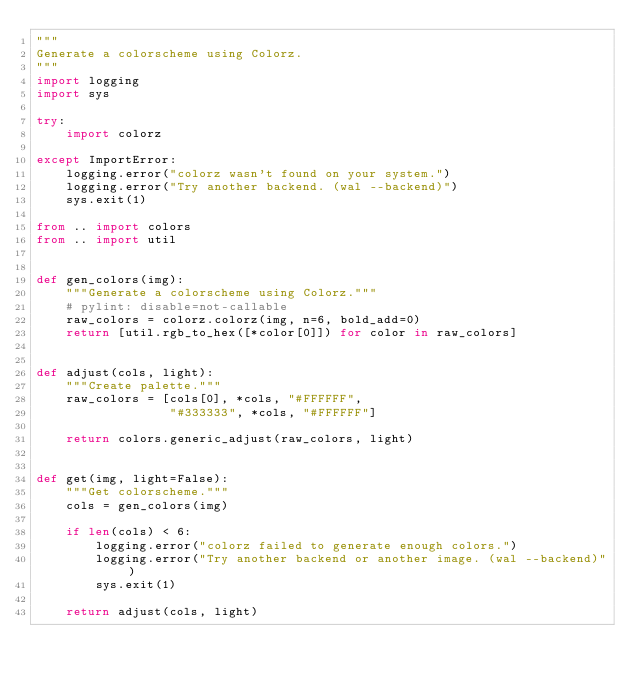Convert code to text. <code><loc_0><loc_0><loc_500><loc_500><_Python_>"""
Generate a colorscheme using Colorz.
"""
import logging
import sys

try:
    import colorz

except ImportError:
    logging.error("colorz wasn't found on your system.")
    logging.error("Try another backend. (wal --backend)")
    sys.exit(1)

from .. import colors
from .. import util


def gen_colors(img):
    """Generate a colorscheme using Colorz."""
    # pylint: disable=not-callable
    raw_colors = colorz.colorz(img, n=6, bold_add=0)
    return [util.rgb_to_hex([*color[0]]) for color in raw_colors]


def adjust(cols, light):
    """Create palette."""
    raw_colors = [cols[0], *cols, "#FFFFFF",
                  "#333333", *cols, "#FFFFFF"]

    return colors.generic_adjust(raw_colors, light)


def get(img, light=False):
    """Get colorscheme."""
    cols = gen_colors(img)

    if len(cols) < 6:
        logging.error("colorz failed to generate enough colors.")
        logging.error("Try another backend or another image. (wal --backend)")
        sys.exit(1)

    return adjust(cols, light)
</code> 